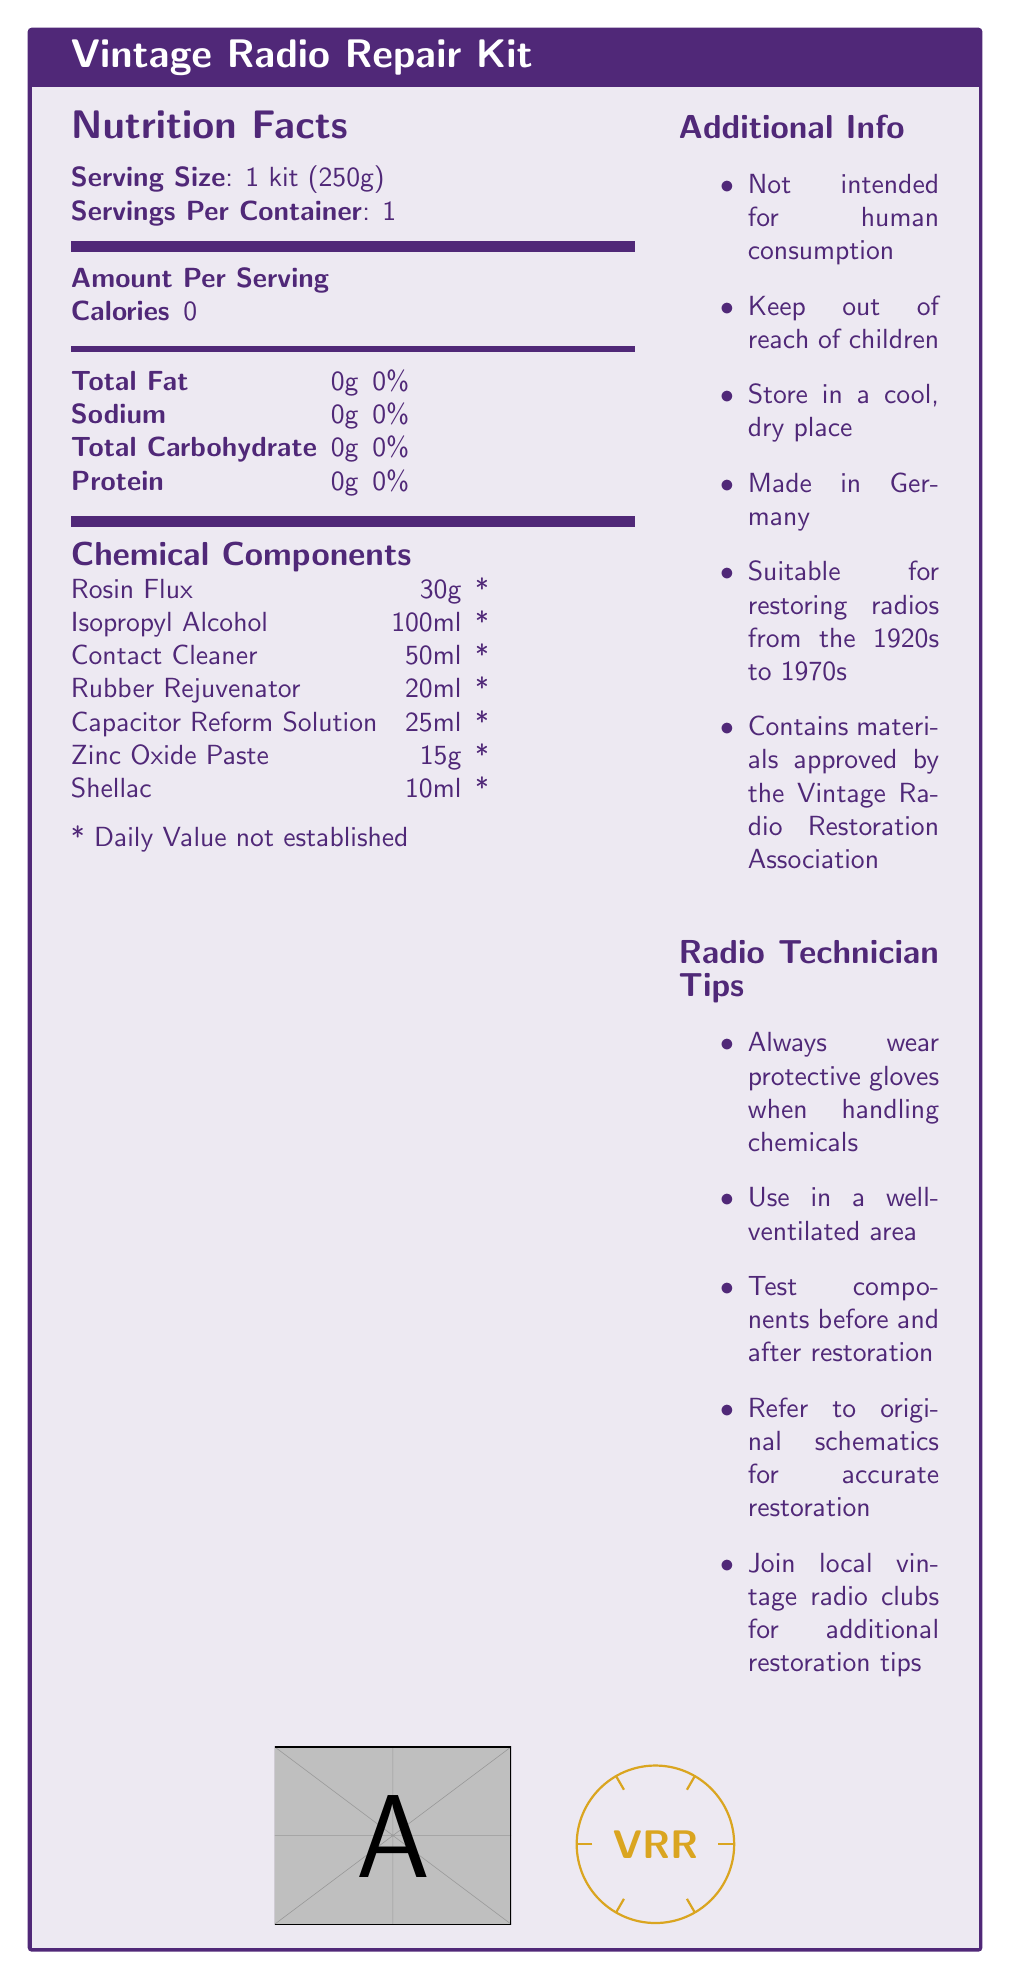what is the serving size? The serving size is explicitly stated in the document as "1 kit (250g)".
Answer: 1 kit (250g) how many chemical components are listed in the document? The document lists 7 chemical components under the "Chemical Components" section.
Answer: 7 what is the amount of Isopropyl Alcohol in the kit? According to the document, the amount of Isopropyl Alcohol is 100ml.
Answer: 100ml what is the purpose of the Contact Cleaner? The document provides a description of each chemical component, and for the Contact Cleaner, it states that it removes oxidation from vintage radio switches and potentiometers.
Answer: Removes oxidation from vintage radio switches and potentiometers is the kit intended for human consumption? The additional info section clearly states "Not intended for human consumption".
Answer: No which of the following components is used for sealing and protecting wooden cabinets? A. Rosin Flux B. Rubber Rejuvenator C. Shellac D. Zinc Oxide Paste The document states that Shellac is "For sealing and protecting restored wooden radio cabinets".
Answer: C. Shellac what should you always wear when handling chemicals in the repair kit? A. Goggles B. Protective gloves C. Mask D. Apron Under the Radio Technician Tips section, it is advised to always wear protective gloves when handling chemicals.
Answer: B. Protective gloves is the kit suitable for radios from the 1980s? The additional info section specifies that the kit is suitable for restoring radios from the 1920s to 1970s.
Answer: No describe the main purpose of the document The document is designed to give radio technicians comprehensive information about the components included in the vintage radio repair kit, their purposes, and best practices for using them.
Answer: The document provides a detailed breakdown of a vintage radio repair kit, including serving size, chemical components, and their uses, as well as additional information and tips for radio technicians. which organization has approved the materials in the kit? The additional info section mentions that the kit contains materials approved by the Vintage Radio Restoration Association.
Answer: Vintage Radio Restoration Association what is the total carbohydrate content of the kit? The nutrition facts section lists the total carbohydrate content as 0g.
Answer: 0g where is the kit made? The additional info section specifies that the kit is made in Germany.
Answer: Germany can you use the kit components in a poorly ventilated area? Radio Technician Tips advises using the kit in a well-ventilated area.
Answer: No what is the percentage of daily value established for the chemical components? The document notes that the daily value for the chemical components is not established.
Answer: Not established how are electrolytic capacitors in vintage radios revived using the kit? The Capacitor Reform Solution is described as helping to revive electrolytic capacitors in vintage radio circuits.
Answer: Using the Capacitor Reform Solution which item in the document provides specific protection advice? A. Chemical Components B. Additional Info C. Radio Technician Tips D. Nutrition Facts The Radio Technician Tips section gives specific advice on protective measures when using the chemicals.
Answer: C. Radio Technician Tips what's the visual symbol included in the document? The end of the document features both an example image and a custom-designed symbol for Vintage Radio Restoration (VRR).
Answer: The document includes an image and a unique symbol with a circle and the initials 'VRR'. 